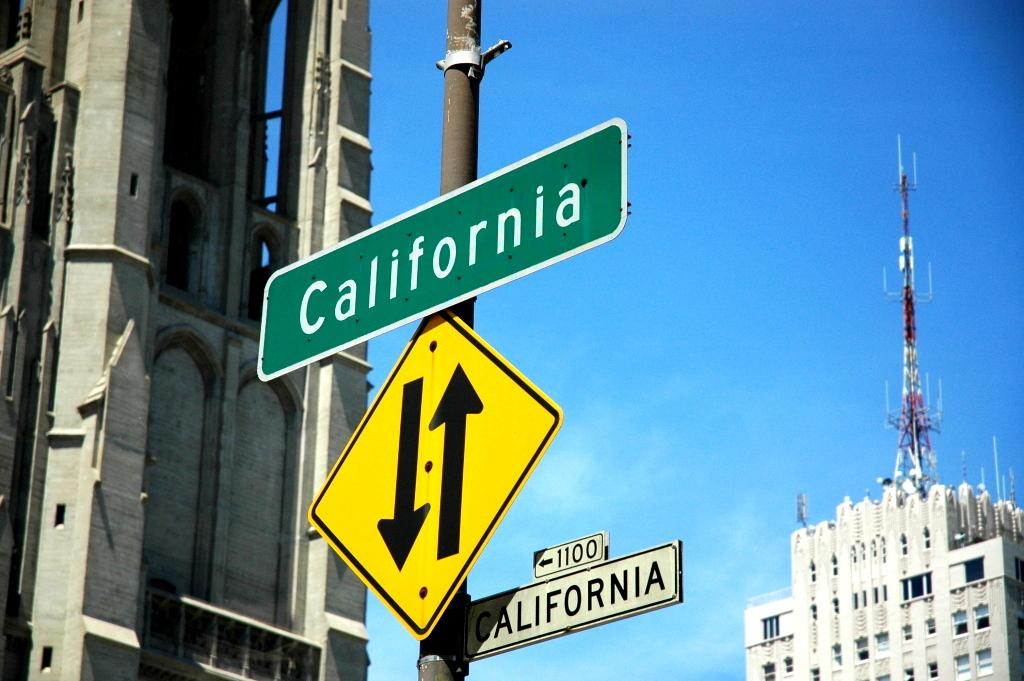<image>
Present a compact description of the photo's key features. a green California street sign is above a two way street sign 